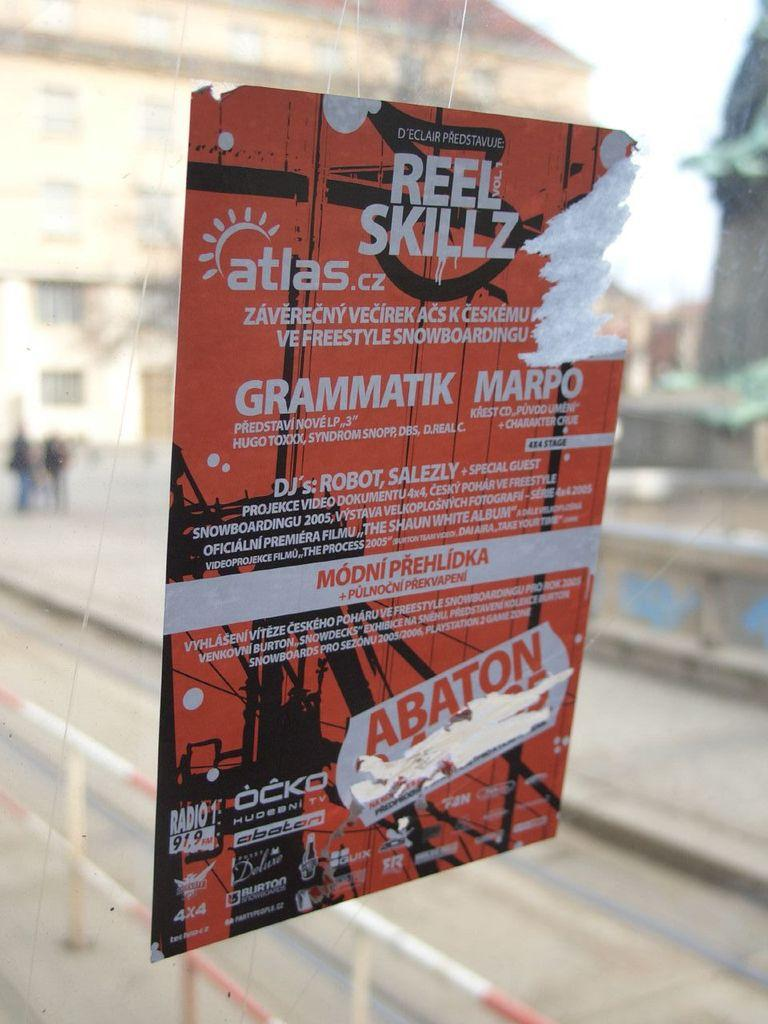<image>
Share a concise interpretation of the image provided. A red and black sticker on glass for Reel Skillz. 